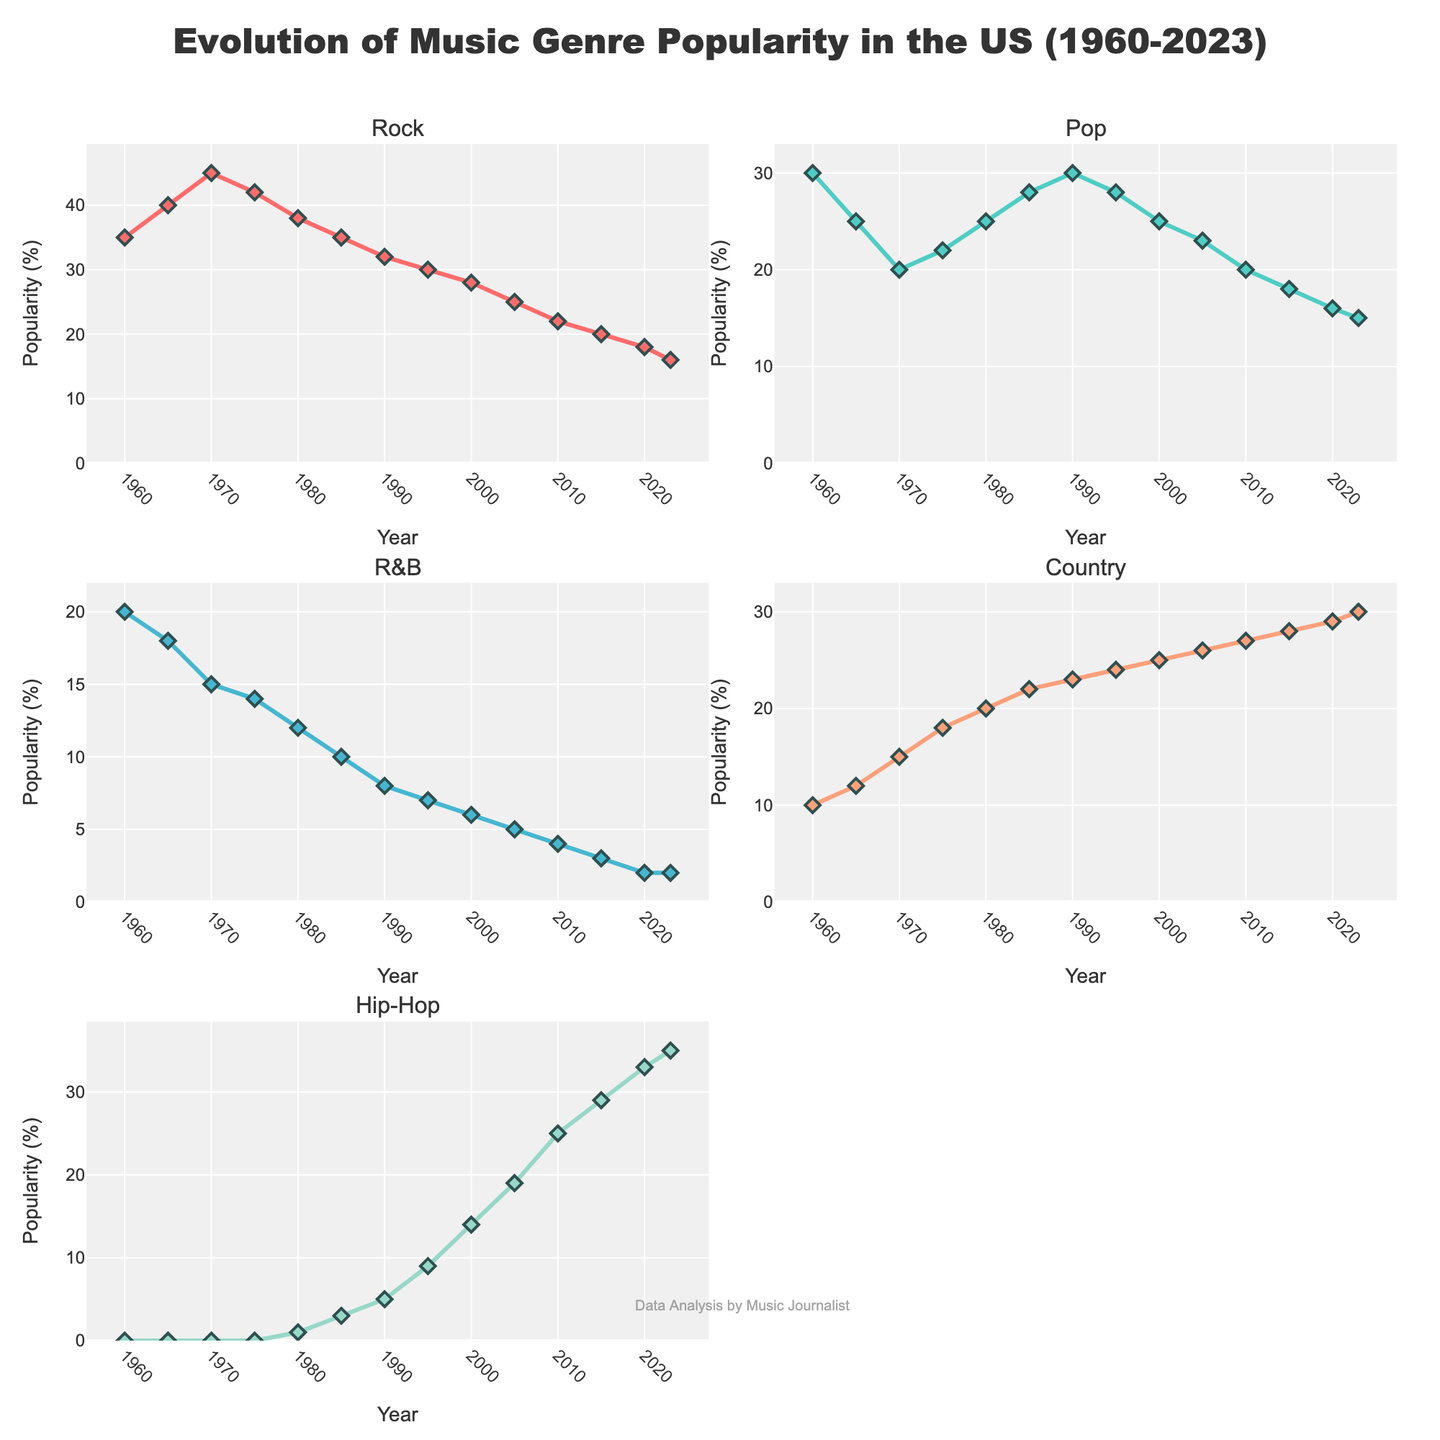How many sitcoms have a frequency of at least 10 for the "Food" theme? Look at the subplot for the "Food" theme. Count the number of bars that have a value of 10 or greater. There are 8 bars meeting this criterion.
Answer: 8 Which sitcom has the highest frequency of "Holidays" references and what is its value? Observe the subplot for "Holidays" and identify the bar with the maximum height. "Shabatot VeHagim" has the highest frequency with a value of 28.
Answer: Shabatot VeHagim, 28 Compare the frequencies of "Military" references between "Eretz Nehederet" and "Zehu Ze!". Which sitcom has more and by how much? Refer to the subplot for "Military" and note the heights of the bars for "Eretz Nehederet" (18) and "Zehu Ze!" (15). Calculate the difference: 18 - 15 = 3.
Answer: Eretz Nehederet, 3 What is the total frequency of references for the "Romance" theme across all sitcoms? Sum the values from the "Romance" subplot: 7 + 15 + 20 + 10 + 12 + 18 + 14 + 9 + 21 + 8 = 134.
Answer: 134 Which theme has the most uniform distribution of references among all sitcoms? Evaluate each subplot to see how evenly the bars are distributed. "Food" and "Family" have relatively small deviations among sitcoms, but "Romance" has noticeable peaks and troughs. "Family" seems the most uniform.
Answer: Family Are there any sitcoms that have the highest frequency in more than one theme? Which ones and in what themes? Scan through the subplots to find sitcoms that appear at the top in multiple themes. "Shabatot VeHagim" has the highest in both "Holidays" (28) and "Romance" (14).
Answer: Shabatot VeHagim, Holidays and Romance Which sitcom has the lowest frequency of "Politics" references and what's the value? Look at the subplot for "Politics" and find the bar with the lowest height. "HaPijamot" has the lowest frequency with a value of 3.
Answer: HaPijamot, 3 For the "Family" theme, what is the average frequency of references across all sitcoms? Add up the "Family" frequencies and divide by the number of sitcoms: (8 + 22 + 25 + 18 + 15 + 23 + 20 + 30 + 16 + 12) / 10 = 189 / 10 = 18.9.
Answer: 18.9 Compare the total references of "Food" and "Military" themes. Which one is higher and by how much? Sum the frequencies for "Food" and "Military" then compare: (15 + 20 + 18 + 22 + 25 + 17 + 12 + 8 + 14 + 16) = 167 for "Food" and (18 + 5 + 7 + 4 + 3 + 8 + 2 + 22 + 10 + 15) = 94 for "Military". The difference is 167 - 94 = 73.
Answer: Food, 73 